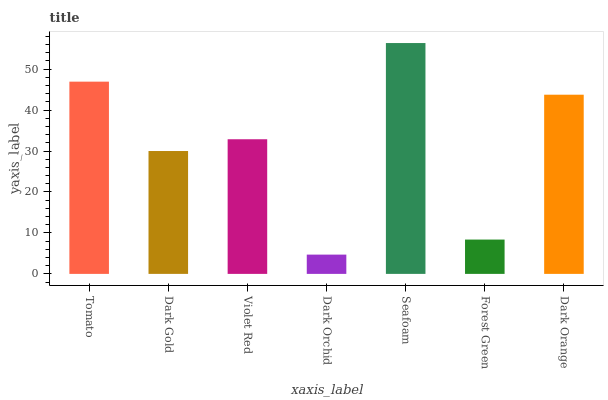Is Dark Orchid the minimum?
Answer yes or no. Yes. Is Seafoam the maximum?
Answer yes or no. Yes. Is Dark Gold the minimum?
Answer yes or no. No. Is Dark Gold the maximum?
Answer yes or no. No. Is Tomato greater than Dark Gold?
Answer yes or no. Yes. Is Dark Gold less than Tomato?
Answer yes or no. Yes. Is Dark Gold greater than Tomato?
Answer yes or no. No. Is Tomato less than Dark Gold?
Answer yes or no. No. Is Violet Red the high median?
Answer yes or no. Yes. Is Violet Red the low median?
Answer yes or no. Yes. Is Dark Orchid the high median?
Answer yes or no. No. Is Forest Green the low median?
Answer yes or no. No. 